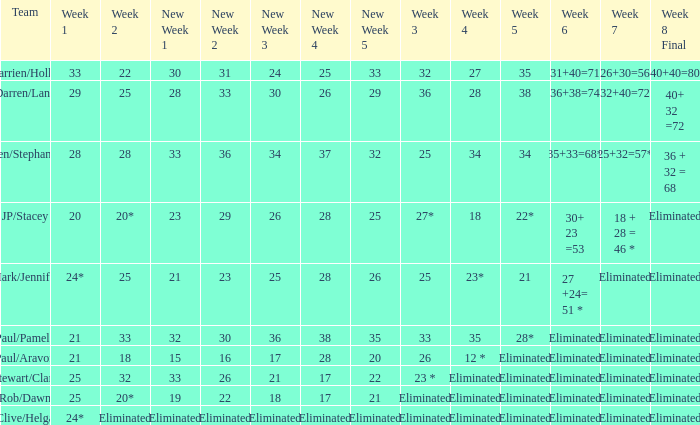Name the week 3 for team of mark/jennifer 25.0. 